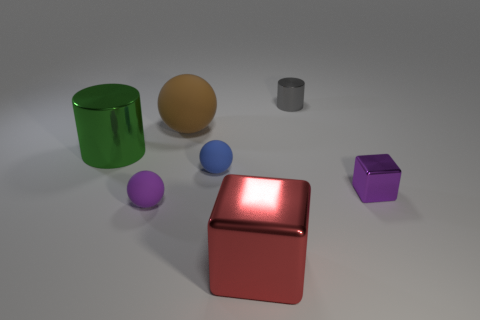What is the shape of the object that is the same color as the small shiny cube?
Make the answer very short. Sphere. There is a object that is the same color as the tiny metal cube; what material is it?
Your answer should be compact. Rubber. What number of large gray rubber cylinders are there?
Ensure brevity in your answer.  0. What material is the small purple thing that is on the right side of the small purple thing that is to the left of the blue matte thing?
Offer a very short reply. Metal. What material is the gray cylinder that is the same size as the purple rubber ball?
Your response must be concise. Metal. There is a block in front of the purple metal cube; does it have the same size as the gray metallic cylinder?
Offer a very short reply. No. There is a small purple thing in front of the small purple metallic object; is it the same shape as the brown object?
Offer a terse response. Yes. What number of objects are big red things or things left of the gray cylinder?
Offer a very short reply. 5. Is the number of small brown shiny spheres less than the number of blue matte things?
Provide a succinct answer. Yes. Is the number of purple things greater than the number of small purple metal objects?
Ensure brevity in your answer.  Yes. 